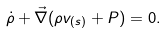Convert formula to latex. <formula><loc_0><loc_0><loc_500><loc_500>\dot { \rho } + \vec { \nabla } ( \rho { v } _ { ( s ) } + { P } ) = 0 .</formula> 